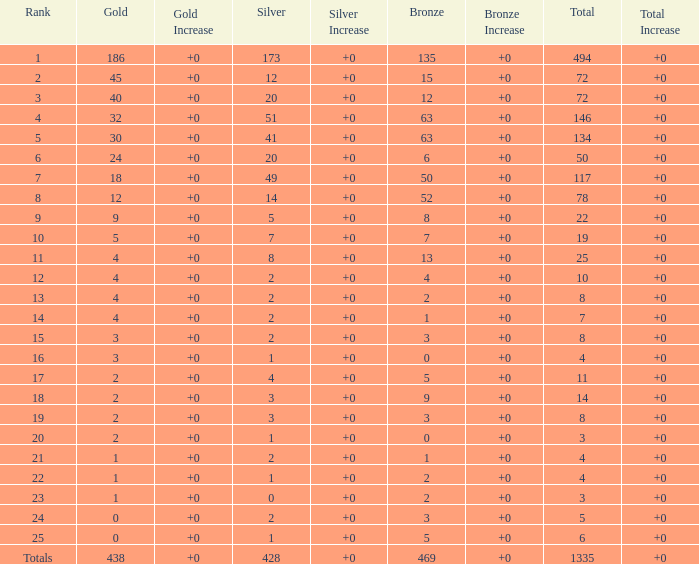What is the average number of gold medals when the total was 1335 medals, with more than 469 bronzes and more than 14 silvers? None. 